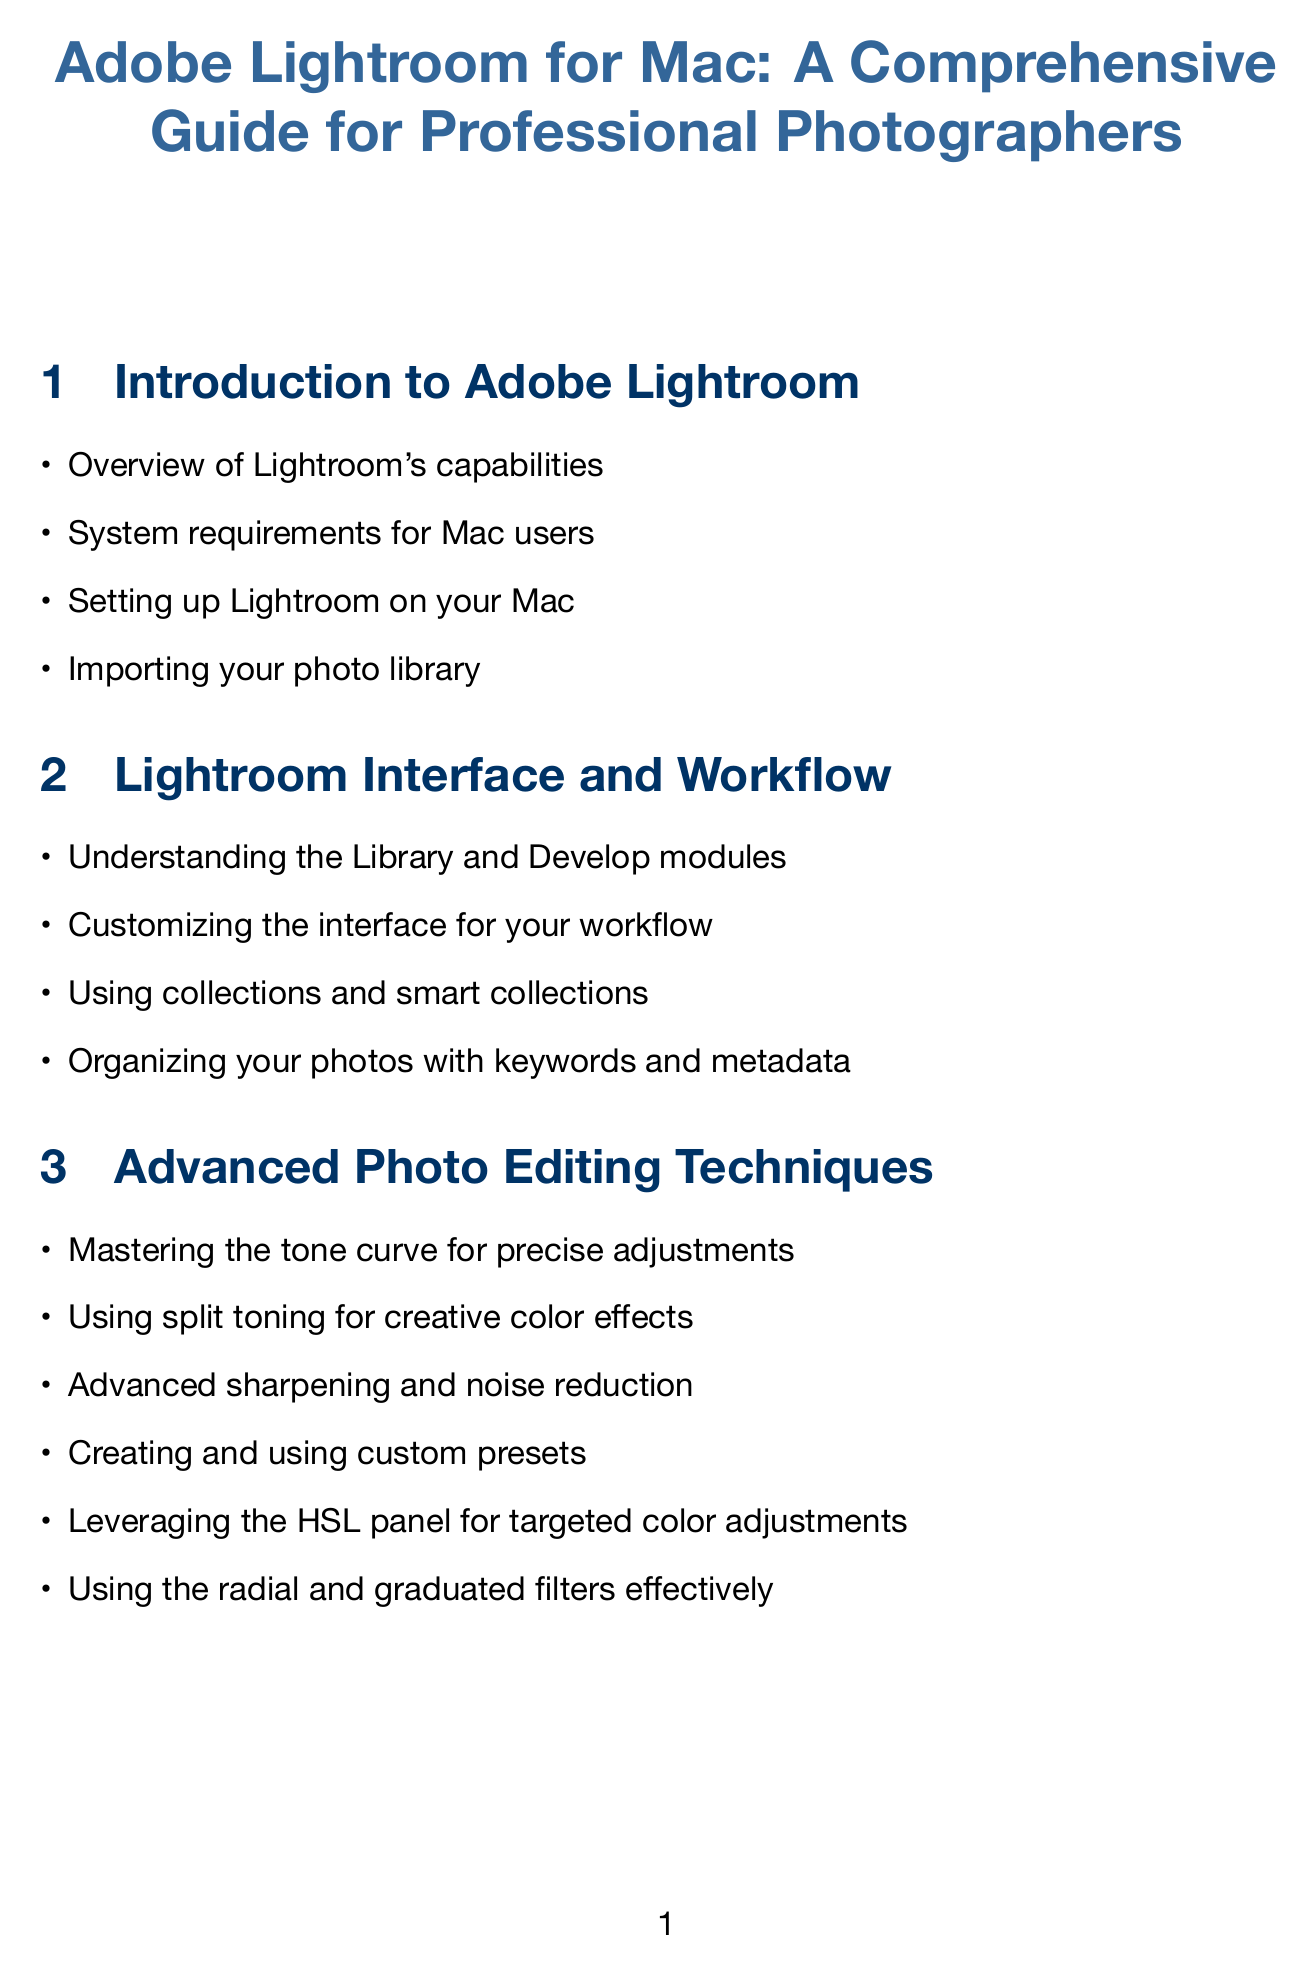What are the system requirements for Mac users? The document must contain information regarding the specific requirements for running Lightroom on Mac, which are listed in the "System requirements for Mac users" section.
Answer: System requirements for Mac users How can you customize the interface in Lightroom? The section on "Customizing the interface for your workflow" covers methods to personalize the Lightroom interface according to user preferences.
Answer: Customizing the interface for your workflow What advanced editing technique involves the HSL panel? The HSL panel is referenced in the section about advanced photo editing techniques and targeted adjustments relating to colors.
Answer: Leveraging the HSL panel for targeted color adjustments What keyboard shortcut is used for the adjustment brush? The document includes a section detailing keyboard shortcuts which would specify the shortcut for the adjustment brush.
Answer: K Which color spaces are discussed in the document? The section on color management outlines relevant information regarding different color spaces available in Lightroom.
Answer: sRGB, Adobe RGB, ProPhoto RGB How can Lightroom's performance be optimized on a Mac? The troubleshooting section contains strategies and tips for improving Lightroom’s performance on a Mac system.
Answer: Optimizing Lightroom's performance on your Mac What is one method for backing up your Lightroom catalog? The backup section includes information on various backup methods available for Lightroom catalogs on Mac.
Answer: Setting up automatic backups of your Lightroom catalog 